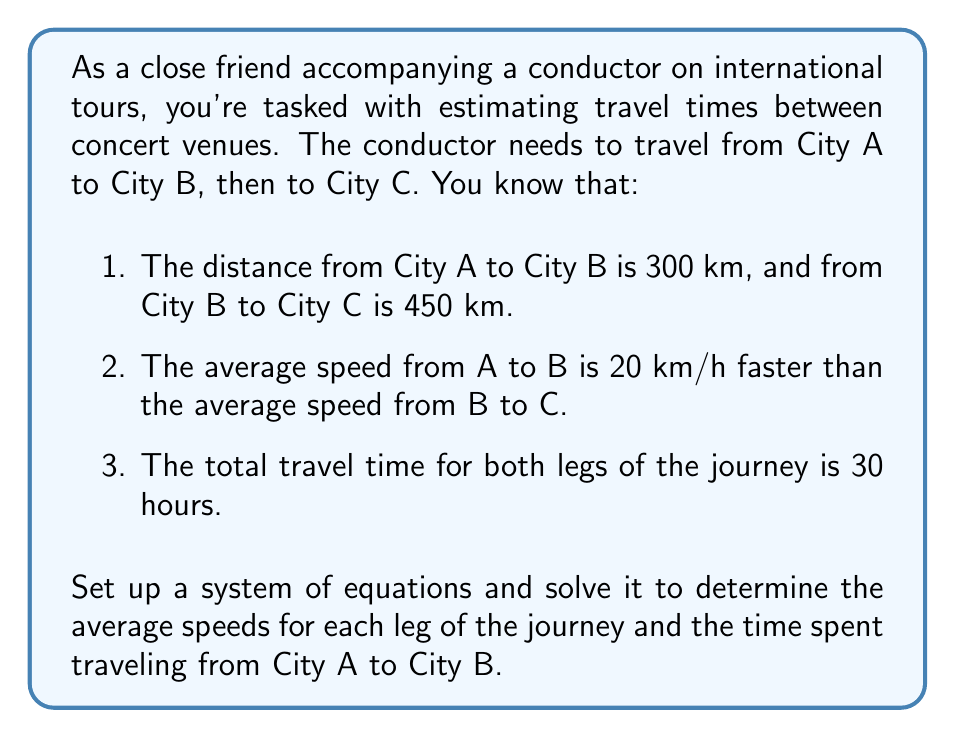Help me with this question. Let's approach this step-by-step:

1) Define variables:
   Let $x$ = average speed from A to B (in km/h)
   Let $y$ = average speed from B to C (in km/h)

2) Set up equations based on the given information:
   Equation 1: $x = y + 20$ (speed from A to B is 20 km/h faster)
   Equation 2: $\frac{300}{x} + \frac{450}{y} = 30$ (total travel time is 30 hours)

3) Substitute $x$ in Equation 2 with $(y + 20)$ from Equation 1:
   $\frac{300}{y + 20} + \frac{450}{y} = 30$

4) Multiply both sides by $y(y + 20)$ to eliminate fractions:
   $300y + 450(y + 20) = 30y(y + 20)$
   $300y + 450y + 9000 = 30y^2 + 600y$
   $30y^2 - 150y - 9000 = 0$

5) This is a quadratic equation. Solve using the quadratic formula:
   $y = \frac{-b \pm \sqrt{b^2 - 4ac}}{2a}$
   Where $a = 30$, $b = -150$, and $c = -9000$

   $y = \frac{150 \pm \sqrt{(-150)^2 - 4(30)(-9000)}}{2(30)}$
   $y = \frac{150 \pm \sqrt{22500 + 1080000}}{60}$
   $y = \frac{150 \pm \sqrt{1102500}}{60}$
   $y = \frac{150 \pm 1050}{60}$

6) This gives us two solutions: $y = 20$ or $y = -10$
   Since speed can't be negative, $y = 20$ km/h

7) Substitute back into Equation 1:
   $x = y + 20 = 20 + 20 = 40$ km/h

8) Calculate time from A to B:
   Time = Distance / Speed = $300 / 40 = 7.5$ hours
Answer: The average speed from City A to City B is 40 km/h, and from City B to City C is 20 km/h. The time spent traveling from City A to City B is 7.5 hours. 